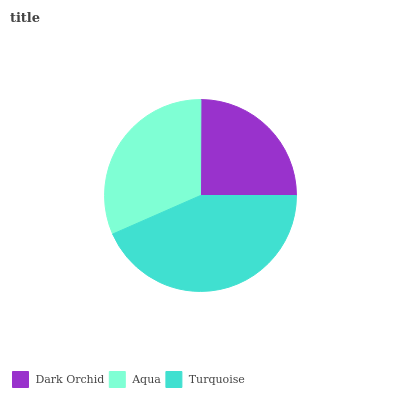Is Dark Orchid the minimum?
Answer yes or no. Yes. Is Turquoise the maximum?
Answer yes or no. Yes. Is Aqua the minimum?
Answer yes or no. No. Is Aqua the maximum?
Answer yes or no. No. Is Aqua greater than Dark Orchid?
Answer yes or no. Yes. Is Dark Orchid less than Aqua?
Answer yes or no. Yes. Is Dark Orchid greater than Aqua?
Answer yes or no. No. Is Aqua less than Dark Orchid?
Answer yes or no. No. Is Aqua the high median?
Answer yes or no. Yes. Is Aqua the low median?
Answer yes or no. Yes. Is Turquoise the high median?
Answer yes or no. No. Is Turquoise the low median?
Answer yes or no. No. 